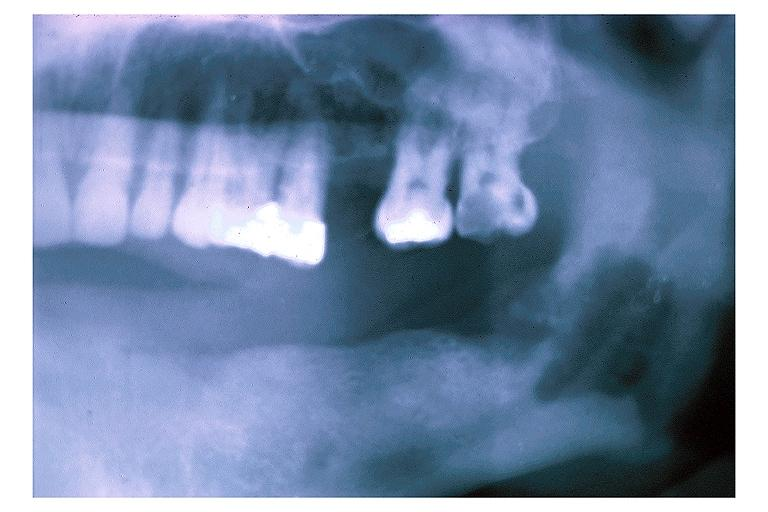s the superior vena cava present?
Answer the question using a single word or phrase. No 